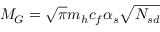<formula> <loc_0><loc_0><loc_500><loc_500>M _ { G } = \sqrt { \pi } m _ { h } c _ { f } \alpha _ { s } \sqrt { N _ { s d } }</formula> 